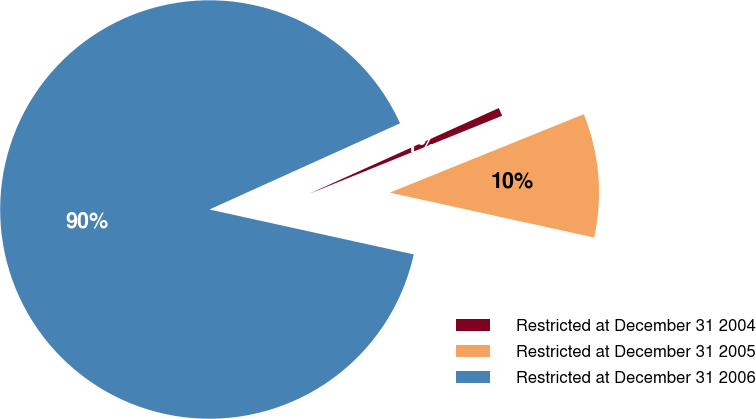Convert chart to OTSL. <chart><loc_0><loc_0><loc_500><loc_500><pie_chart><fcel>Restricted at December 31 2004<fcel>Restricted at December 31 2005<fcel>Restricted at December 31 2006<nl><fcel>0.64%<fcel>9.56%<fcel>89.81%<nl></chart> 